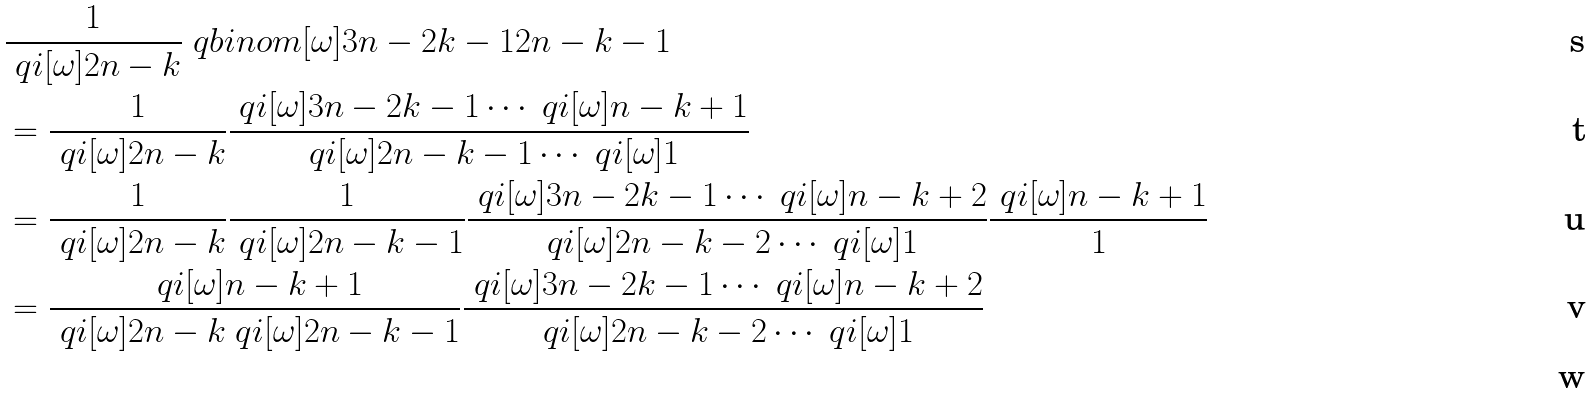Convert formula to latex. <formula><loc_0><loc_0><loc_500><loc_500>& \frac { 1 } { \ q i [ \omega ] { 2 n - k } } \ q b i n o m [ \omega ] { 3 n - 2 k - 1 } { 2 n - k - 1 } \\ & = \frac { 1 } { \ q i [ \omega ] { 2 n - k } } \frac { \ q i [ \omega ] { 3 n - 2 k - 1 } \cdots \ q i [ \omega ] { n - k + 1 } } { \ q i [ \omega ] { 2 n - k - 1 } \cdots \ q i [ \omega ] { 1 } } \\ & = \frac { 1 } { \ q i [ \omega ] { 2 n - k } } \frac { 1 } { \ q i [ \omega ] { 2 n - k - 1 } } \frac { \ q i [ \omega ] { 3 n - 2 k - 1 } \cdots \ q i [ \omega ] { n - k + 2 } } { \ q i [ \omega ] { 2 n - k - 2 } \cdots \ q i [ \omega ] { 1 } } \frac { \ q i [ \omega ] { n - k + 1 } } { 1 } \\ & = \frac { \ q i [ \omega ] { n - k + 1 } } { \ q i [ \omega ] { 2 n - k } \ q i [ \omega ] { 2 n - k - 1 } } \frac { \ q i [ \omega ] { 3 n - 2 k - 1 } \cdots \ q i [ \omega ] { n - k + 2 } } { \ q i [ \omega ] { 2 n - k - 2 } \cdots \ q i [ \omega ] { 1 } } \\</formula> 